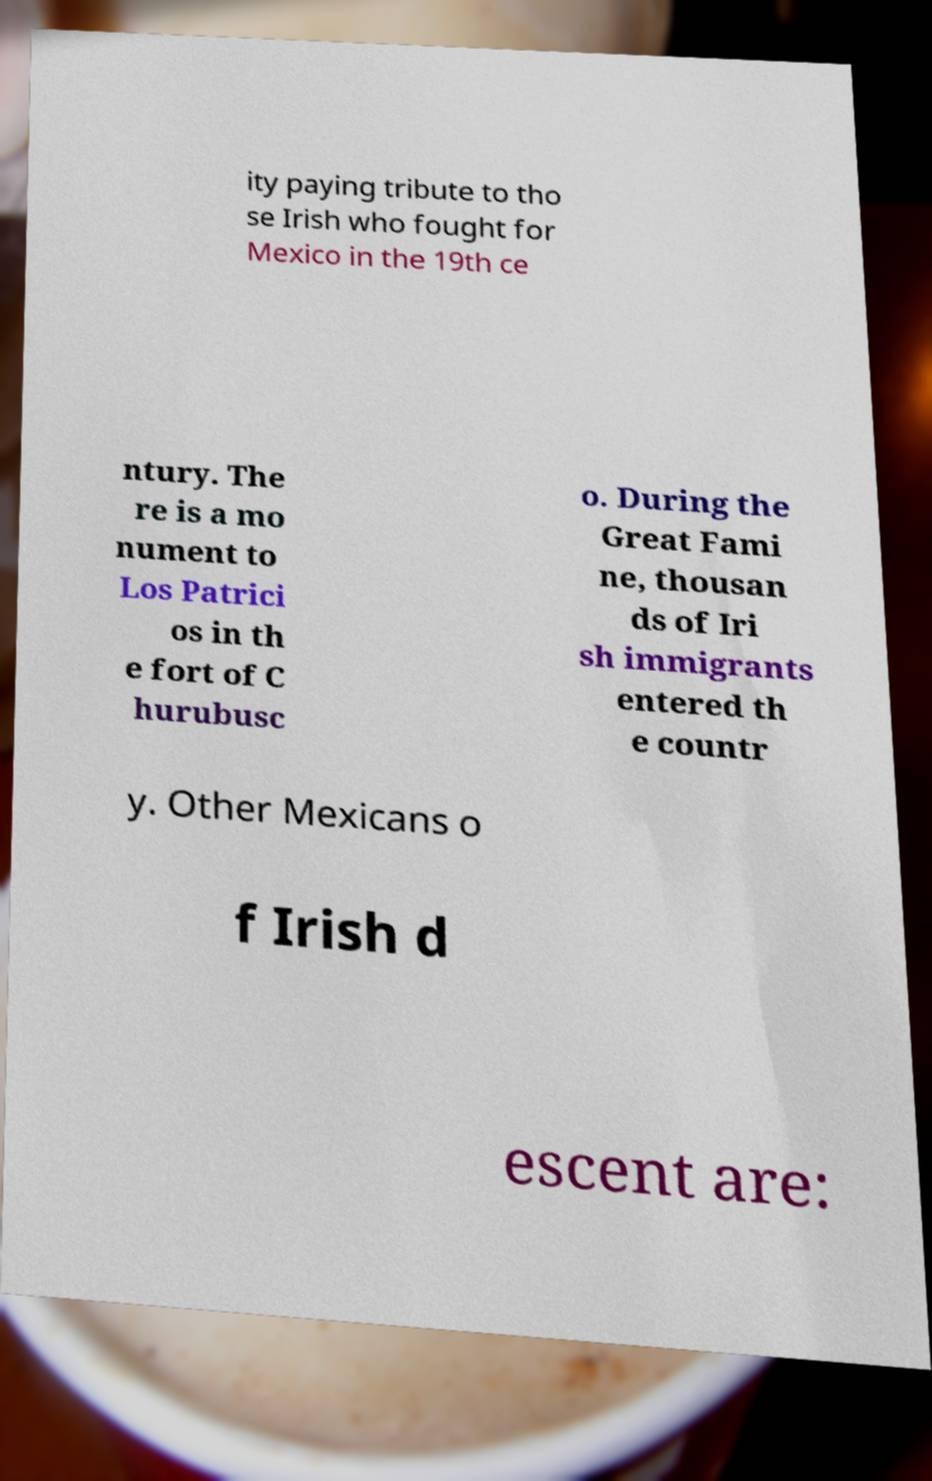I need the written content from this picture converted into text. Can you do that? ity paying tribute to tho se Irish who fought for Mexico in the 19th ce ntury. The re is a mo nument to Los Patrici os in th e fort of C hurubusc o. During the Great Fami ne, thousan ds of Iri sh immigrants entered th e countr y. Other Mexicans o f Irish d escent are: 